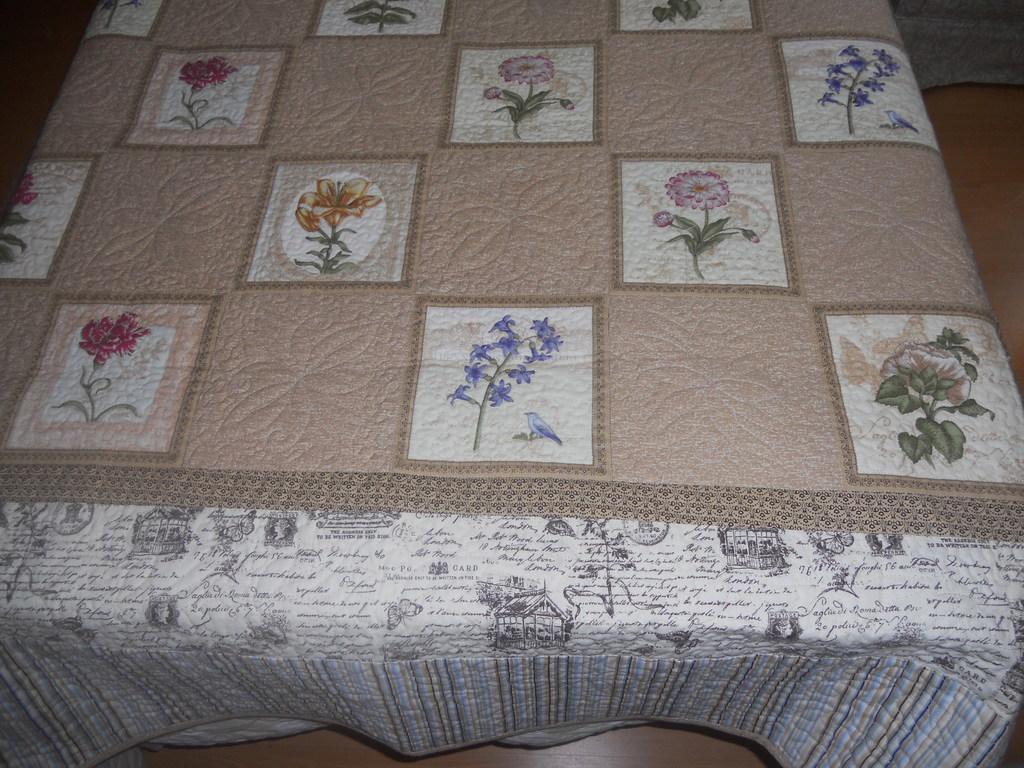Can you describe this image briefly? In this image we can see a cloth on which group of flower designs are made is placed on a table. 